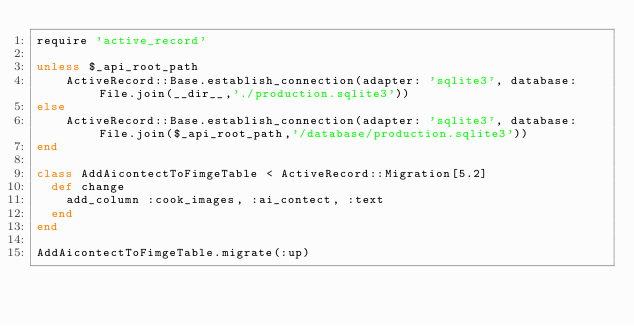<code> <loc_0><loc_0><loc_500><loc_500><_Ruby_>require 'active_record'

unless $_api_root_path
    ActiveRecord::Base.establish_connection(adapter: 'sqlite3', database: File.join(__dir__,'./production.sqlite3'))
else
    ActiveRecord::Base.establish_connection(adapter: 'sqlite3', database: File.join($_api_root_path,'/database/production.sqlite3'))
end

class AddAicontectToFimgeTable < ActiveRecord::Migration[5.2]
  def change
    add_column :cook_images, :ai_contect, :text
  end
end

AddAicontectToFimgeTable.migrate(:up)</code> 